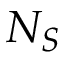Convert formula to latex. <formula><loc_0><loc_0><loc_500><loc_500>N _ { S }</formula> 